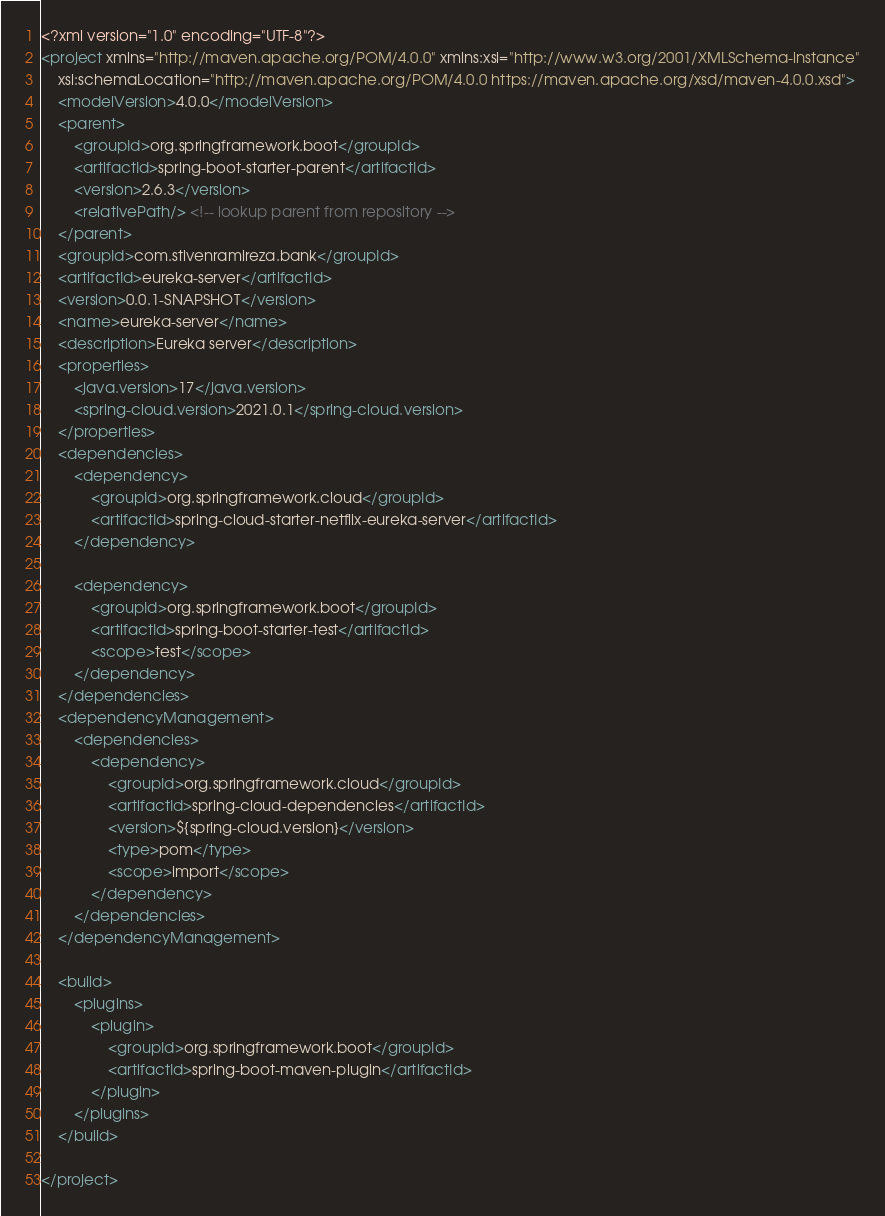<code> <loc_0><loc_0><loc_500><loc_500><_XML_><?xml version="1.0" encoding="UTF-8"?>
<project xmlns="http://maven.apache.org/POM/4.0.0" xmlns:xsi="http://www.w3.org/2001/XMLSchema-instance"
	xsi:schemaLocation="http://maven.apache.org/POM/4.0.0 https://maven.apache.org/xsd/maven-4.0.0.xsd">
	<modelVersion>4.0.0</modelVersion>
	<parent>
		<groupId>org.springframework.boot</groupId>
		<artifactId>spring-boot-starter-parent</artifactId>
		<version>2.6.3</version>
		<relativePath/> <!-- lookup parent from repository -->
	</parent>
	<groupId>com.stivenramireza.bank</groupId>
	<artifactId>eureka-server</artifactId>
	<version>0.0.1-SNAPSHOT</version>
	<name>eureka-server</name>
	<description>Eureka server</description>
	<properties>
		<java.version>17</java.version>
		<spring-cloud.version>2021.0.1</spring-cloud.version>
	</properties>
	<dependencies>
		<dependency>
			<groupId>org.springframework.cloud</groupId>
			<artifactId>spring-cloud-starter-netflix-eureka-server</artifactId>
		</dependency>

		<dependency>
			<groupId>org.springframework.boot</groupId>
			<artifactId>spring-boot-starter-test</artifactId>
			<scope>test</scope>
		</dependency>
	</dependencies>
	<dependencyManagement>
		<dependencies>
			<dependency>
				<groupId>org.springframework.cloud</groupId>
				<artifactId>spring-cloud-dependencies</artifactId>
				<version>${spring-cloud.version}</version>
				<type>pom</type>
				<scope>import</scope>
			</dependency>
		</dependencies>
	</dependencyManagement>

	<build>
		<plugins>
			<plugin>
				<groupId>org.springframework.boot</groupId>
				<artifactId>spring-boot-maven-plugin</artifactId>
			</plugin>
		</plugins>
	</build>

</project>
</code> 